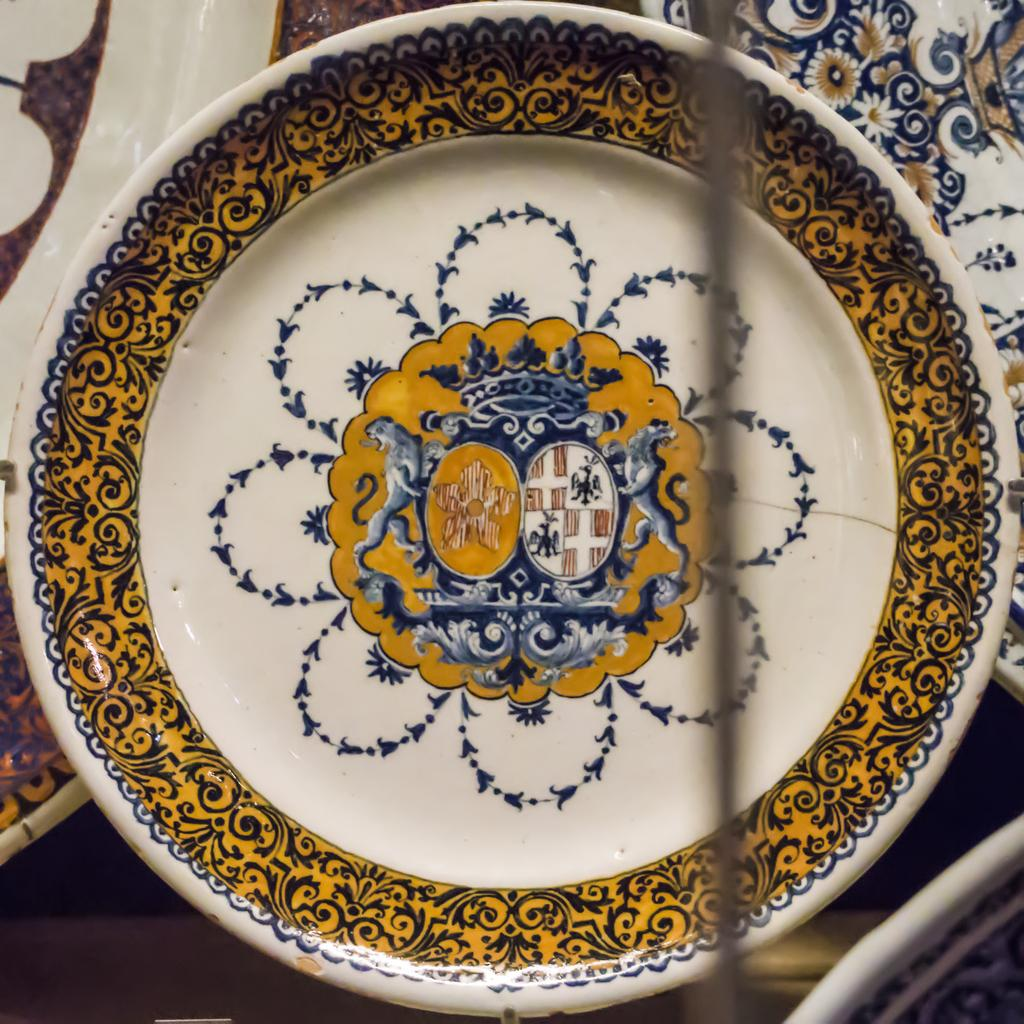What objects can be seen in the image? There are plates in the image. What is unique about the plates? The plates have images on their surface. Where are the plates located in the image? The plates are placed on a surface that resembles a floor. How many giants are visible in the image? There are no giants present in the image. What does the queen do in the image? There is no queen present in the image. 